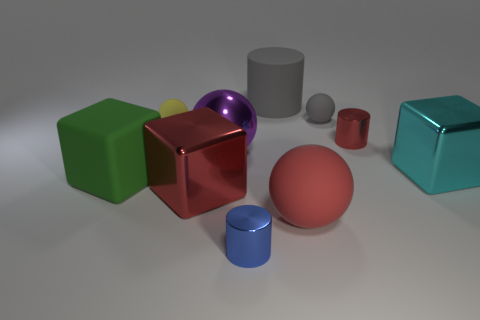Can you describe the lighting in the scene? The lighting in the scene is soft and diffused, with no harsh shadows visible. It seems to come from a source above the arrangement of objects, providing an even illumination that gently highlights the shapes of the objects. Does the lighting affect the color perception of the objects? Yes, the lighting can influence how we perceive the colors of the objects. Soft lighting can make colors appear more muted and less vibrant, while also reducing the contrast between light and shadow, contributing to a more uniform look of the objects' colors. 